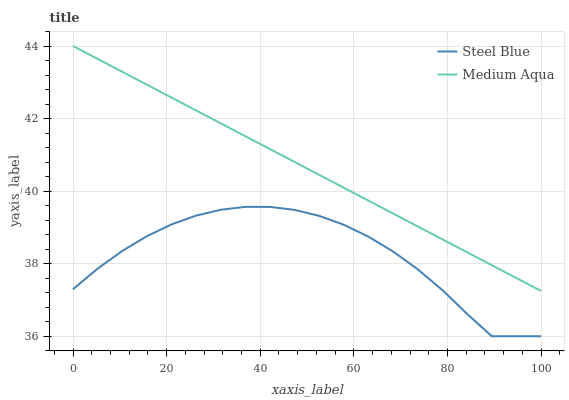Does Steel Blue have the maximum area under the curve?
Answer yes or no. No. Is Steel Blue the smoothest?
Answer yes or no. No. Does Steel Blue have the highest value?
Answer yes or no. No. Is Steel Blue less than Medium Aqua?
Answer yes or no. Yes. Is Medium Aqua greater than Steel Blue?
Answer yes or no. Yes. Does Steel Blue intersect Medium Aqua?
Answer yes or no. No. 